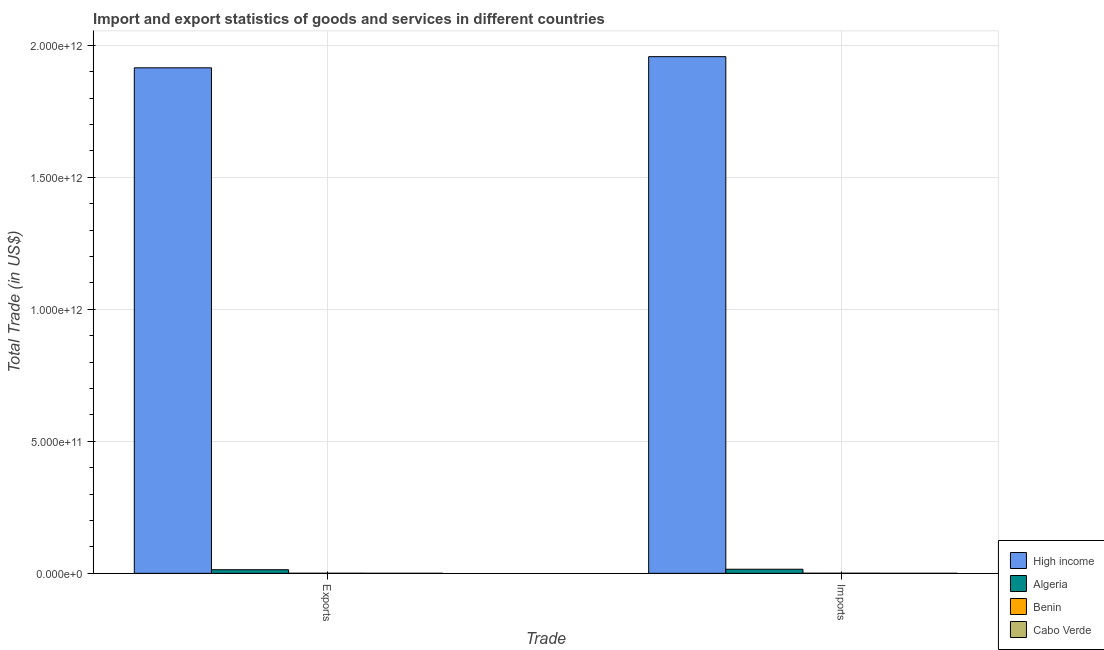Are the number of bars per tick equal to the number of legend labels?
Make the answer very short. Yes. Are the number of bars on each tick of the X-axis equal?
Your answer should be compact. Yes. How many bars are there on the 2nd tick from the right?
Keep it short and to the point. 4. What is the label of the 2nd group of bars from the left?
Make the answer very short. Imports. What is the imports of goods and services in High income?
Offer a terse response. 1.96e+12. Across all countries, what is the maximum export of goods and services?
Your answer should be compact. 1.91e+12. Across all countries, what is the minimum imports of goods and services?
Make the answer very short. 1.09e+08. In which country was the imports of goods and services maximum?
Your answer should be very brief. High income. In which country was the imports of goods and services minimum?
Ensure brevity in your answer.  Cabo Verde. What is the total export of goods and services in the graph?
Provide a short and direct response. 1.93e+12. What is the difference between the imports of goods and services in Benin and that in High income?
Ensure brevity in your answer.  -1.96e+12. What is the difference between the imports of goods and services in Algeria and the export of goods and services in Cabo Verde?
Your response must be concise. 1.55e+1. What is the average imports of goods and services per country?
Your answer should be very brief. 4.93e+11. What is the difference between the imports of goods and services and export of goods and services in High income?
Your answer should be very brief. 4.23e+1. In how many countries, is the imports of goods and services greater than 1300000000000 US$?
Make the answer very short. 1. What is the ratio of the imports of goods and services in Algeria to that in Cabo Verde?
Offer a terse response. 142.07. In how many countries, is the imports of goods and services greater than the average imports of goods and services taken over all countries?
Keep it short and to the point. 1. What does the 3rd bar from the left in Imports represents?
Offer a very short reply. Benin. What does the 1st bar from the right in Imports represents?
Your answer should be very brief. Cabo Verde. How many bars are there?
Your response must be concise. 8. Are all the bars in the graph horizontal?
Keep it short and to the point. No. What is the difference between two consecutive major ticks on the Y-axis?
Offer a very short reply. 5.00e+11. Are the values on the major ticks of Y-axis written in scientific E-notation?
Ensure brevity in your answer.  Yes. Does the graph contain grids?
Your answer should be compact. Yes. How are the legend labels stacked?
Provide a succinct answer. Vertical. What is the title of the graph?
Offer a terse response. Import and export statistics of goods and services in different countries. Does "Japan" appear as one of the legend labels in the graph?
Offer a very short reply. No. What is the label or title of the X-axis?
Offer a very short reply. Trade. What is the label or title of the Y-axis?
Provide a short and direct response. Total Trade (in US$). What is the Total Trade (in US$) in High income in Exports?
Make the answer very short. 1.91e+12. What is the Total Trade (in US$) of Algeria in Exports?
Give a very brief answer. 1.37e+1. What is the Total Trade (in US$) in Benin in Exports?
Provide a succinct answer. 2.47e+08. What is the Total Trade (in US$) in Cabo Verde in Exports?
Offer a terse response. 3.12e+07. What is the Total Trade (in US$) of High income in Imports?
Provide a short and direct response. 1.96e+12. What is the Total Trade (in US$) in Algeria in Imports?
Your answer should be compact. 1.55e+1. What is the Total Trade (in US$) of Benin in Imports?
Provide a succinct answer. 3.83e+08. What is the Total Trade (in US$) in Cabo Verde in Imports?
Offer a very short reply. 1.09e+08. Across all Trade, what is the maximum Total Trade (in US$) in High income?
Your answer should be compact. 1.96e+12. Across all Trade, what is the maximum Total Trade (in US$) of Algeria?
Your response must be concise. 1.55e+1. Across all Trade, what is the maximum Total Trade (in US$) in Benin?
Ensure brevity in your answer.  3.83e+08. Across all Trade, what is the maximum Total Trade (in US$) in Cabo Verde?
Offer a very short reply. 1.09e+08. Across all Trade, what is the minimum Total Trade (in US$) in High income?
Give a very brief answer. 1.91e+12. Across all Trade, what is the minimum Total Trade (in US$) in Algeria?
Provide a short and direct response. 1.37e+1. Across all Trade, what is the minimum Total Trade (in US$) in Benin?
Provide a short and direct response. 2.47e+08. Across all Trade, what is the minimum Total Trade (in US$) of Cabo Verde?
Offer a terse response. 3.12e+07. What is the total Total Trade (in US$) of High income in the graph?
Make the answer very short. 3.87e+12. What is the total Total Trade (in US$) of Algeria in the graph?
Provide a short and direct response. 2.92e+1. What is the total Total Trade (in US$) of Benin in the graph?
Ensure brevity in your answer.  6.31e+08. What is the total Total Trade (in US$) of Cabo Verde in the graph?
Ensure brevity in your answer.  1.40e+08. What is the difference between the Total Trade (in US$) of High income in Exports and that in Imports?
Your response must be concise. -4.23e+1. What is the difference between the Total Trade (in US$) of Algeria in Exports and that in Imports?
Ensure brevity in your answer.  -1.83e+09. What is the difference between the Total Trade (in US$) in Benin in Exports and that in Imports?
Your answer should be very brief. -1.36e+08. What is the difference between the Total Trade (in US$) of Cabo Verde in Exports and that in Imports?
Offer a terse response. -7.79e+07. What is the difference between the Total Trade (in US$) in High income in Exports and the Total Trade (in US$) in Algeria in Imports?
Your response must be concise. 1.90e+12. What is the difference between the Total Trade (in US$) in High income in Exports and the Total Trade (in US$) in Benin in Imports?
Provide a succinct answer. 1.91e+12. What is the difference between the Total Trade (in US$) in High income in Exports and the Total Trade (in US$) in Cabo Verde in Imports?
Make the answer very short. 1.91e+12. What is the difference between the Total Trade (in US$) of Algeria in Exports and the Total Trade (in US$) of Benin in Imports?
Your answer should be very brief. 1.33e+1. What is the difference between the Total Trade (in US$) in Algeria in Exports and the Total Trade (in US$) in Cabo Verde in Imports?
Your answer should be compact. 1.36e+1. What is the difference between the Total Trade (in US$) of Benin in Exports and the Total Trade (in US$) of Cabo Verde in Imports?
Make the answer very short. 1.38e+08. What is the average Total Trade (in US$) in High income per Trade?
Offer a terse response. 1.94e+12. What is the average Total Trade (in US$) of Algeria per Trade?
Provide a succinct answer. 1.46e+1. What is the average Total Trade (in US$) of Benin per Trade?
Your response must be concise. 3.15e+08. What is the average Total Trade (in US$) of Cabo Verde per Trade?
Give a very brief answer. 7.01e+07. What is the difference between the Total Trade (in US$) in High income and Total Trade (in US$) in Algeria in Exports?
Give a very brief answer. 1.90e+12. What is the difference between the Total Trade (in US$) in High income and Total Trade (in US$) in Benin in Exports?
Your response must be concise. 1.91e+12. What is the difference between the Total Trade (in US$) in High income and Total Trade (in US$) in Cabo Verde in Exports?
Keep it short and to the point. 1.91e+12. What is the difference between the Total Trade (in US$) in Algeria and Total Trade (in US$) in Benin in Exports?
Make the answer very short. 1.34e+1. What is the difference between the Total Trade (in US$) of Algeria and Total Trade (in US$) of Cabo Verde in Exports?
Make the answer very short. 1.36e+1. What is the difference between the Total Trade (in US$) in Benin and Total Trade (in US$) in Cabo Verde in Exports?
Offer a terse response. 2.16e+08. What is the difference between the Total Trade (in US$) in High income and Total Trade (in US$) in Algeria in Imports?
Make the answer very short. 1.94e+12. What is the difference between the Total Trade (in US$) of High income and Total Trade (in US$) of Benin in Imports?
Offer a very short reply. 1.96e+12. What is the difference between the Total Trade (in US$) of High income and Total Trade (in US$) of Cabo Verde in Imports?
Make the answer very short. 1.96e+12. What is the difference between the Total Trade (in US$) in Algeria and Total Trade (in US$) in Benin in Imports?
Make the answer very short. 1.51e+1. What is the difference between the Total Trade (in US$) of Algeria and Total Trade (in US$) of Cabo Verde in Imports?
Ensure brevity in your answer.  1.54e+1. What is the difference between the Total Trade (in US$) in Benin and Total Trade (in US$) in Cabo Verde in Imports?
Offer a very short reply. 2.74e+08. What is the ratio of the Total Trade (in US$) of High income in Exports to that in Imports?
Give a very brief answer. 0.98. What is the ratio of the Total Trade (in US$) of Algeria in Exports to that in Imports?
Your answer should be very brief. 0.88. What is the ratio of the Total Trade (in US$) in Benin in Exports to that in Imports?
Your answer should be very brief. 0.65. What is the ratio of the Total Trade (in US$) in Cabo Verde in Exports to that in Imports?
Provide a succinct answer. 0.29. What is the difference between the highest and the second highest Total Trade (in US$) in High income?
Ensure brevity in your answer.  4.23e+1. What is the difference between the highest and the second highest Total Trade (in US$) of Algeria?
Offer a very short reply. 1.83e+09. What is the difference between the highest and the second highest Total Trade (in US$) of Benin?
Keep it short and to the point. 1.36e+08. What is the difference between the highest and the second highest Total Trade (in US$) of Cabo Verde?
Provide a short and direct response. 7.79e+07. What is the difference between the highest and the lowest Total Trade (in US$) in High income?
Your answer should be compact. 4.23e+1. What is the difference between the highest and the lowest Total Trade (in US$) of Algeria?
Your response must be concise. 1.83e+09. What is the difference between the highest and the lowest Total Trade (in US$) in Benin?
Your response must be concise. 1.36e+08. What is the difference between the highest and the lowest Total Trade (in US$) in Cabo Verde?
Offer a terse response. 7.79e+07. 